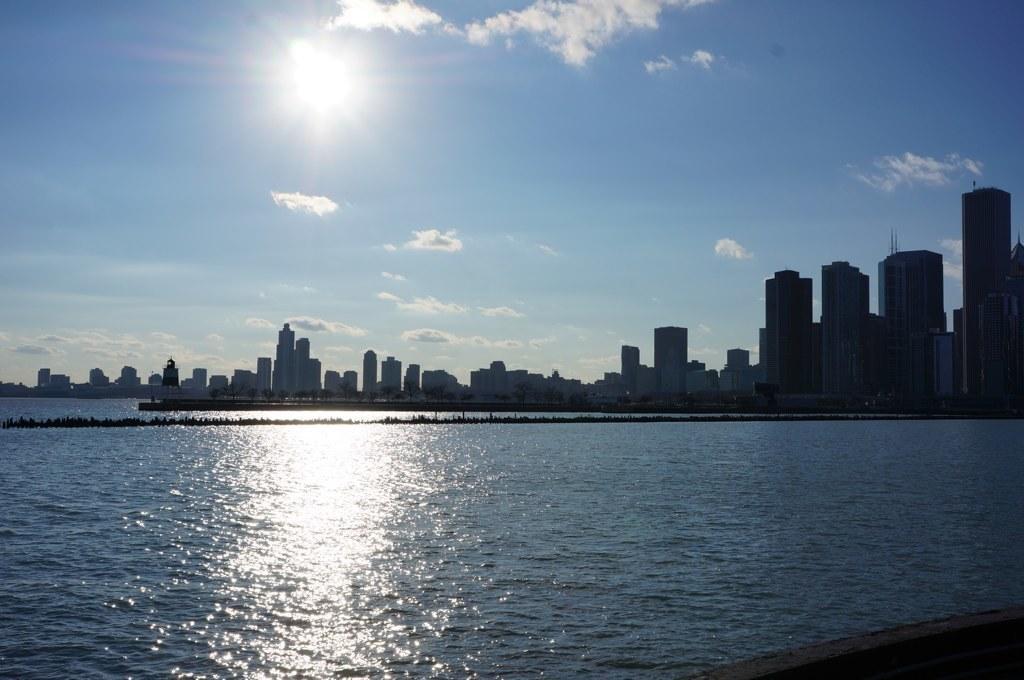Could you give a brief overview of what you see in this image? this picture shows sea and buildings adjacent to it and a blue cloudy sky with sun 